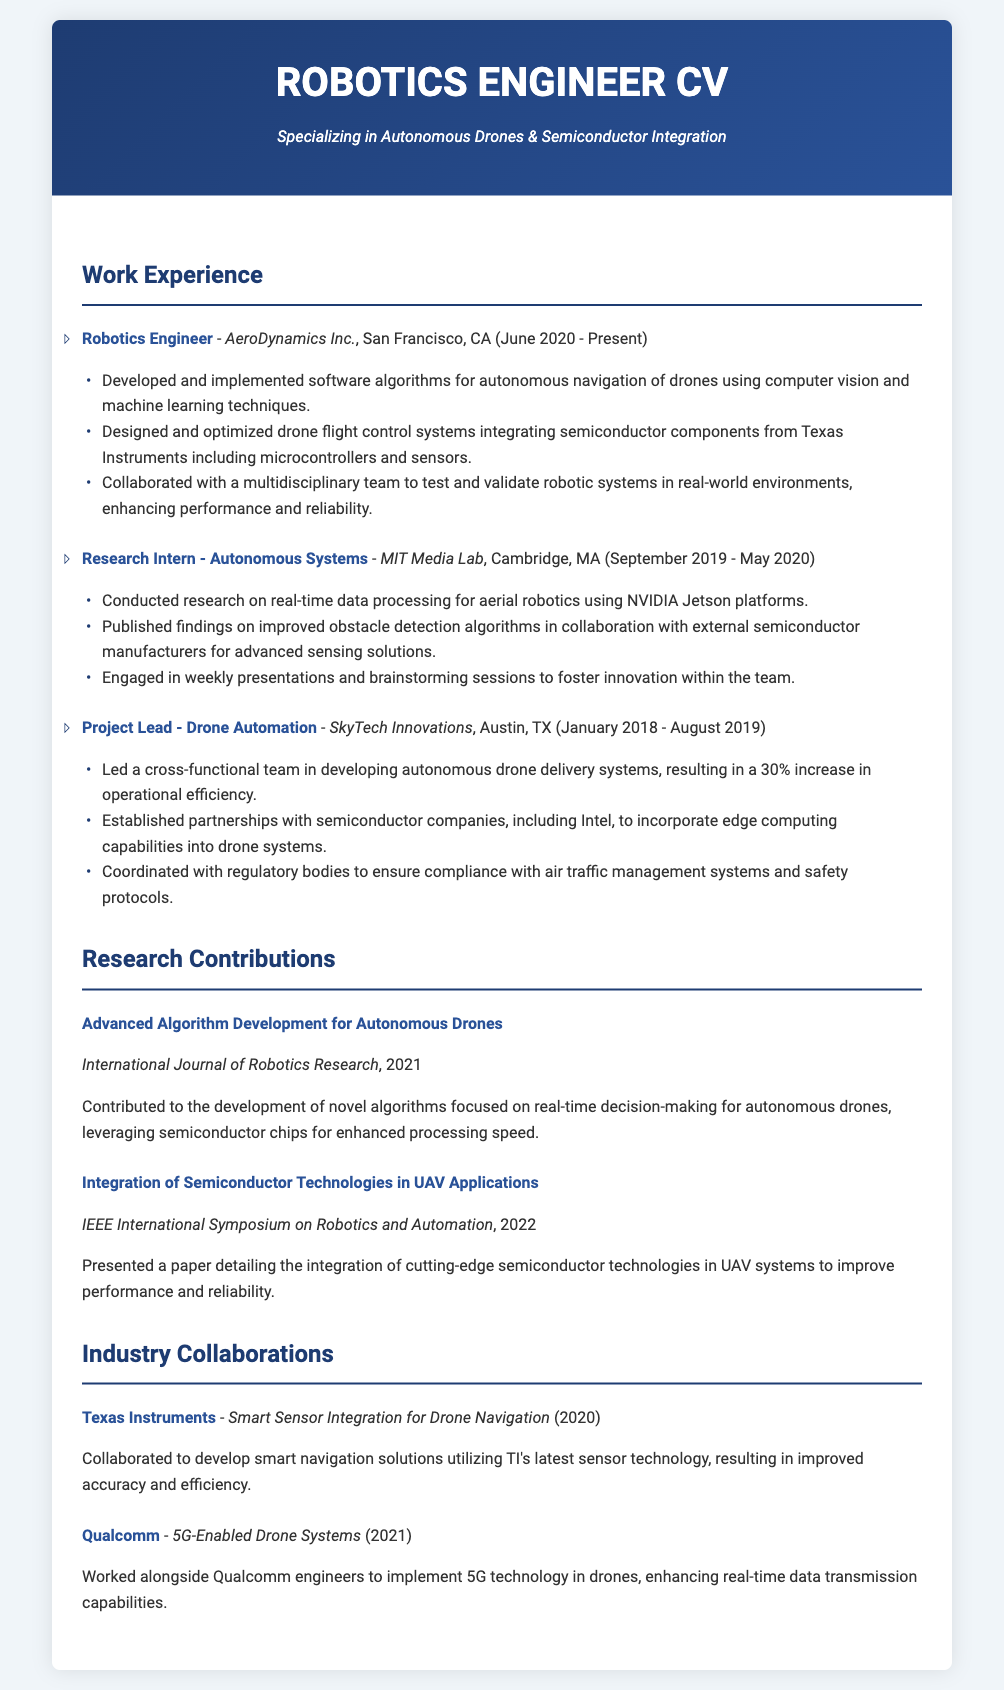What is the job title at AeroDynamics Inc.? The job title at AeroDynamics Inc. is Robotics Engineer, as mentioned in the relevant section.
Answer: Robotics Engineer When did the research internship at MIT Media Lab take place? The research internship took place from September 2019 to May 2020, as the dates are explicitly stated.
Answer: September 2019 - May 2020 What is one technology integrated into drone systems at SkyTech Innovations? The document mentions edge computing capabilities as a technology integrated into drone systems at SkyTech Innovations, which relates to collaborations with semiconductor companies.
Answer: Edge computing Which publication featured the research on advanced algorithm development? The International Journal of Robotics Research is cited in the document as the publication for this research.
Answer: International Journal of Robotics Research Who is the collaboration partner for the 5G-enabled drone systems project? Qualcomm is identified as the partner for this project in the collaboration section of the document.
Answer: Qualcomm What percentage increase in operational efficiency did the drone delivery systems achieve? The document states that there was a 30% increase in operational efficiency due to the project leading at SkyTech Innovations.
Answer: 30% What type of roles does the CV emphasize? The CV emphasizes roles in robotics projects, research contributions, and collaborations with semiconductor manufacturers, as seen throughout the sections.
Answer: Robotics projects In which year was the paper on the integration of semiconductor technologies presented? The IEEE International Symposium on Robotics and Automation featured the paper, which was presented in 2022.
Answer: 2022 What company collaborated on smart sensor integration for drone navigation? Texas Instruments is mentioned as the collaboration partner for developing smart navigation solutions utilizing their sensor technology.
Answer: Texas Instruments 